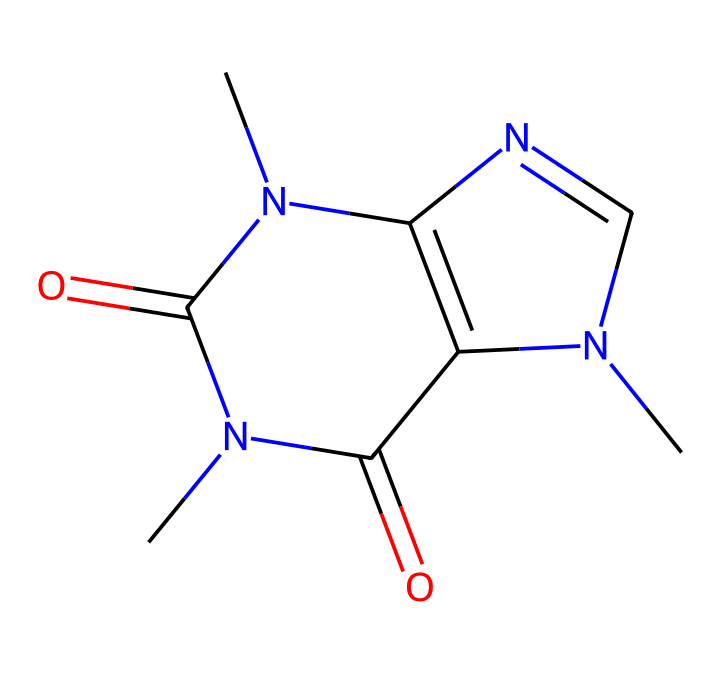What is the molecular formula of caffeine? By analyzing the SMILES representation, we identify the atoms present: there are 8 carbon atoms (C), 10 hydrogen atoms (H), 4 nitrogen atoms (N), and 2 oxygen atoms (O). Therefore, the molecular formula can be constructed as C8H10N4O2.
Answer: C8H10N4O2 How many nitrogen atoms are present in caffeine? The SMILES notation indicates four distinct nitrogen atoms marked by "N" in the structure, which can be counted directly from the formula representation.
Answer: 4 Is caffeine a pyrimidine or purine alkaloid? By examining the structure, we can see that caffeine has a cyclic structure typical of purines, specifically containing a fused bicyclic system that matches the features of purine alkaloids.
Answer: purine How many rings are present in the structure of caffeine? The determined structure shows two interconnected rings, which can be visualized from the representations of benzene-like and azole rings in the molecule.
Answer: 2 What characteristic feature gives caffeine its stimulant properties? Caffeine contains multiple nitrogen atoms in its structure; specifically, their positioning allows for interactions with adenosine receptors in the brain, which accounts for its stimulating effects.
Answer: nitrogen atoms What does the presence of oxygen in the structure indicate about caffeine's properties? The two oxygen atoms in caffeine are part of carbonyl groups (C=O), which influence solubility and reactivity, indicative of its ability to interact with biological systems and contribute to its metabolic processes.
Answer: solubility and reactivity 